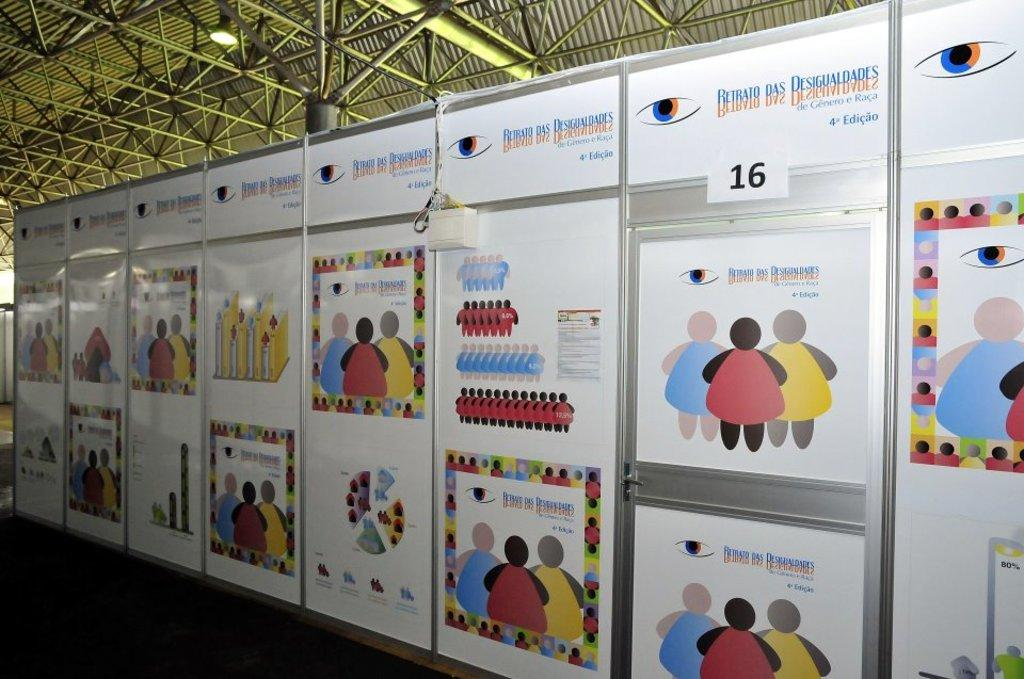<image>
Provide a brief description of the given image. A large display covers an entire wall and is dedicated to the 4th Edition publication of a certain book. 